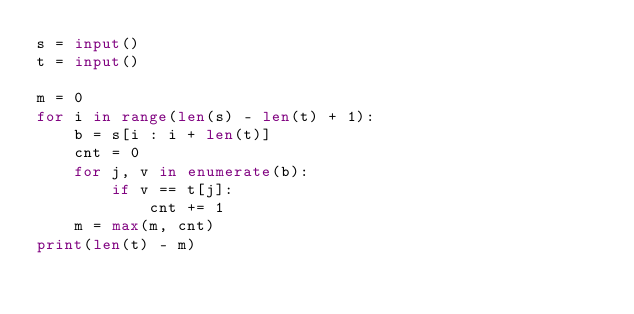<code> <loc_0><loc_0><loc_500><loc_500><_Python_>s = input()
t = input()

m = 0
for i in range(len(s) - len(t) + 1):
    b = s[i : i + len(t)]
    cnt = 0
    for j, v in enumerate(b):
        if v == t[j]:
            cnt += 1
    m = max(m, cnt)
print(len(t) - m)
</code> 